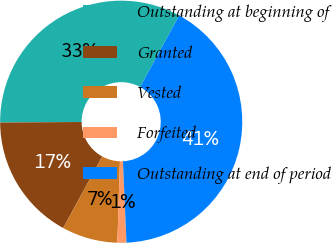Convert chart. <chart><loc_0><loc_0><loc_500><loc_500><pie_chart><fcel>Outstanding at beginning of<fcel>Granted<fcel>Vested<fcel>Forfeited<fcel>Outstanding at end of period<nl><fcel>33.06%<fcel>16.94%<fcel>7.45%<fcel>1.2%<fcel>41.35%<nl></chart> 